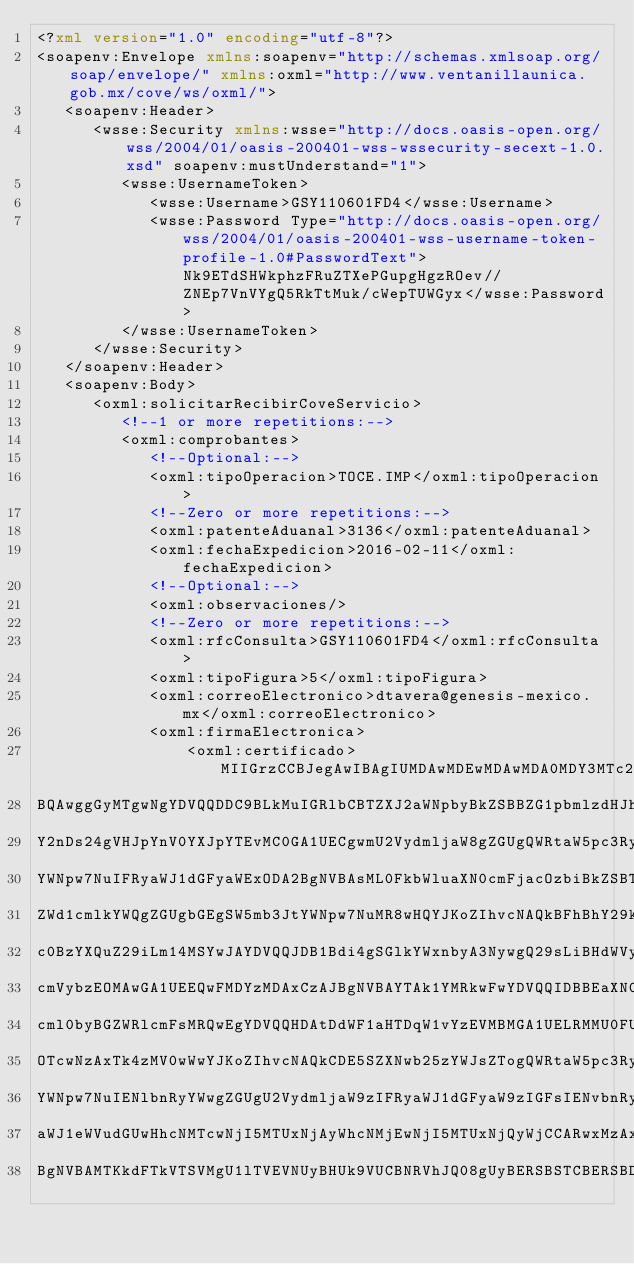<code> <loc_0><loc_0><loc_500><loc_500><_XML_><?xml version="1.0" encoding="utf-8"?>
<soapenv:Envelope xmlns:soapenv="http://schemas.xmlsoap.org/soap/envelope/" xmlns:oxml="http://www.ventanillaunica.gob.mx/cove/ws/oxml/">
   <soapenv:Header>
      <wsse:Security xmlns:wsse="http://docs.oasis-open.org/wss/2004/01/oasis-200401-wss-wssecurity-secext-1.0.xsd" soapenv:mustUnderstand="1">
         <wsse:UsernameToken>
            <wsse:Username>GSY110601FD4</wsse:Username>
            <wsse:Password Type="http://docs.oasis-open.org/wss/2004/01/oasis-200401-wss-username-token-profile-1.0#PasswordText">Nk9ETdSHWkphzFRuZTXePGupgHgzROev//ZNEp7VnVYgQ5RkTtMuk/cWepTUWGyx</wsse:Password>
         </wsse:UsernameToken>
      </wsse:Security>
   </soapenv:Header>
   <soapenv:Body>
      <oxml:solicitarRecibirCoveServicio>
         <!--1 or more repetitions:-->
         <oxml:comprobantes>
            <!--Optional:-->            
            <oxml:tipoOperacion>TOCE.IMP</oxml:tipoOperacion>
            <!--Zero or more repetitions:-->
            <oxml:patenteAduanal>3136</oxml:patenteAduanal>
            <oxml:fechaExpedicion>2016-02-11</oxml:fechaExpedicion>
            <!--Optional:-->
            <oxml:observaciones/>
            <!--Zero or more repetitions:-->
            <oxml:rfcConsulta>GSY110601FD4</oxml:rfcConsulta>
            <oxml:tipoFigura>5</oxml:tipoFigura>
            <oxml:correoElectronico>dtavera@genesis-mexico.mx</oxml:correoElectronico>
            <oxml:firmaElectronica>
            	<oxml:certificado>MIIGrzCCBJegAwIBAgIUMDAwMDEwMDAwMDA0MDY3MTc2MTcwDQYJKoZIhvcNAQEL
BQAwggGyMTgwNgYDVQQDDC9BLkMuIGRlbCBTZXJ2aWNpbyBkZSBBZG1pbmlzdHJh
Y2nDs24gVHJpYnV0YXJpYTEvMC0GA1UECgwmU2VydmljaW8gZGUgQWRtaW5pc3Ry
YWNpw7NuIFRyaWJ1dGFyaWExODA2BgNVBAsML0FkbWluaXN0cmFjacOzbiBkZSBT
ZWd1cmlkYWQgZGUgbGEgSW5mb3JtYWNpw7NuMR8wHQYJKoZIhvcNAQkBFhBhY29k
c0BzYXQuZ29iLm14MSYwJAYDVQQJDB1Bdi4gSGlkYWxnbyA3NywgQ29sLiBHdWVy
cmVybzEOMAwGA1UEEQwFMDYzMDAxCzAJBgNVBAYTAk1YMRkwFwYDVQQIDBBEaXN0
cml0byBGZWRlcmFsMRQwEgYDVQQHDAtDdWF1aHTDqW1vYzEVMBMGA1UELRMMU0FU
OTcwNzAxTk4zMV0wWwYJKoZIhvcNAQkCDE5SZXNwb25zYWJsZTogQWRtaW5pc3Ry
YWNpw7NuIENlbnRyYWwgZGUgU2VydmljaW9zIFRyaWJ1dGFyaW9zIGFsIENvbnRy
aWJ1eWVudGUwHhcNMTcwNjI5MTUxNjAyWhcNMjEwNjI5MTUxNjQyWjCCARwxMzAx
BgNVBAMTKkdFTkVTSVMgU1lTVEVNUyBHUk9VUCBNRVhJQ08gUyBERSBSTCBERSBD</code> 